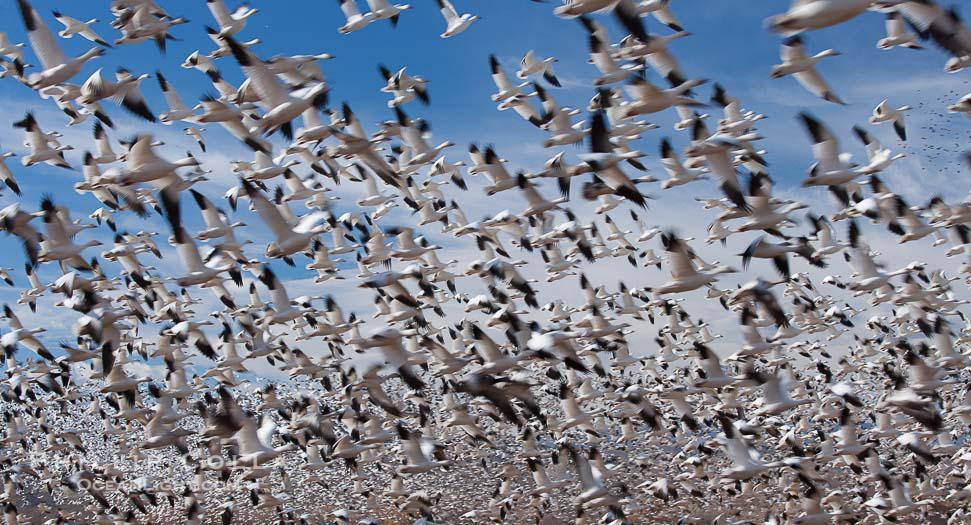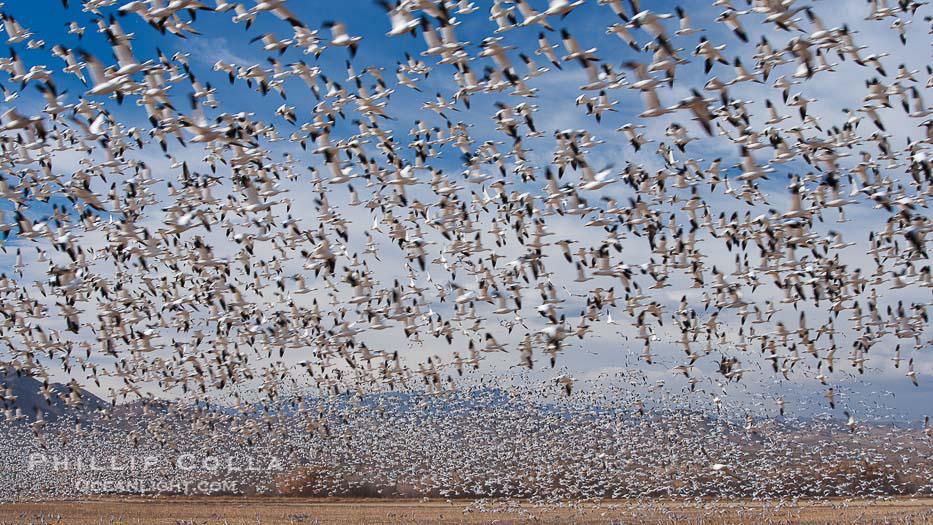The first image is the image on the left, the second image is the image on the right. Considering the images on both sides, is "In at least one of the images, you can see the ground at the bottom of the frame." valid? Answer yes or no. Yes. The first image is the image on the left, the second image is the image on the right. Given the left and right images, does the statement "A horizon is visible behind a mass of flying birds in at least one image, and no image has any one bird that stands out as different from the rest." hold true? Answer yes or no. Yes. 